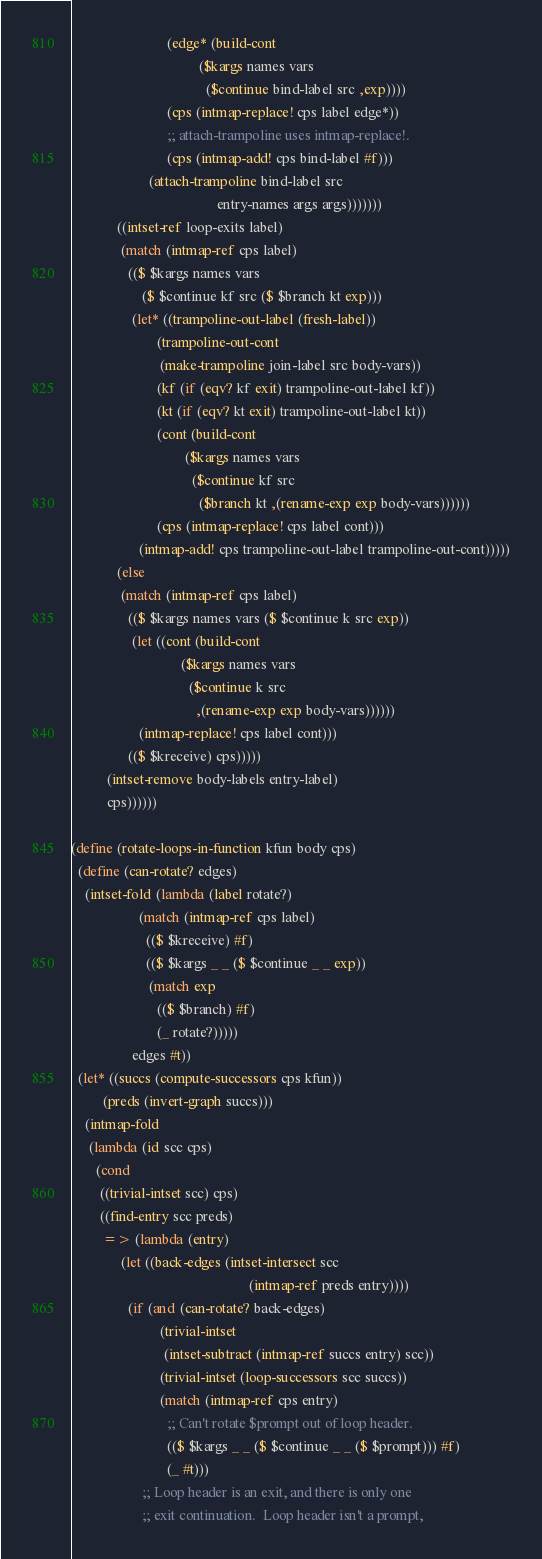Convert code to text. <code><loc_0><loc_0><loc_500><loc_500><_Scheme_>                           (edge* (build-cont
                                    ($kargs names vars
                                      ($continue bind-label src ,exp))))
                           (cps (intmap-replace! cps label edge*))
                           ;; attach-trampoline uses intmap-replace!.
                           (cps (intmap-add! cps bind-label #f)))
                      (attach-trampoline bind-label src
                                         entry-names args args)))))))
             ((intset-ref loop-exits label)
              (match (intmap-ref cps label)
                (($ $kargs names vars
                    ($ $continue kf src ($ $branch kt exp)))
                 (let* ((trampoline-out-label (fresh-label))
                        (trampoline-out-cont
                         (make-trampoline join-label src body-vars))
                        (kf (if (eqv? kf exit) trampoline-out-label kf))
                        (kt (if (eqv? kt exit) trampoline-out-label kt))
                        (cont (build-cont
                                ($kargs names vars
                                  ($continue kf src
                                    ($branch kt ,(rename-exp exp body-vars))))))
                        (cps (intmap-replace! cps label cont)))
                   (intmap-add! cps trampoline-out-label trampoline-out-cont)))))
             (else
              (match (intmap-ref cps label)
                (($ $kargs names vars ($ $continue k src exp))
                 (let ((cont (build-cont
                               ($kargs names vars
                                 ($continue k src
                                   ,(rename-exp exp body-vars))))))
                   (intmap-replace! cps label cont)))
                (($ $kreceive) cps)))))
          (intset-remove body-labels entry-label)
          cps))))))

(define (rotate-loops-in-function kfun body cps)
  (define (can-rotate? edges)
    (intset-fold (lambda (label rotate?)
                   (match (intmap-ref cps label)
                     (($ $kreceive) #f)
                     (($ $kargs _ _ ($ $continue _ _ exp))
                      (match exp
                        (($ $branch) #f)
                        (_ rotate?)))))
                 edges #t))
  (let* ((succs (compute-successors cps kfun))
         (preds (invert-graph succs)))
    (intmap-fold
     (lambda (id scc cps)
       (cond
        ((trivial-intset scc) cps)
        ((find-entry scc preds)
         => (lambda (entry)
              (let ((back-edges (intset-intersect scc
                                                  (intmap-ref preds entry))))
                (if (and (can-rotate? back-edges)
                         (trivial-intset
                          (intset-subtract (intmap-ref succs entry) scc))
                         (trivial-intset (loop-successors scc succs))
                         (match (intmap-ref cps entry)
                           ;; Can't rotate $prompt out of loop header.
                           (($ $kargs _ _ ($ $continue _ _ ($ $prompt))) #f)
                           (_ #t)))
                    ;; Loop header is an exit, and there is only one
                    ;; exit continuation.  Loop header isn't a prompt,</code> 